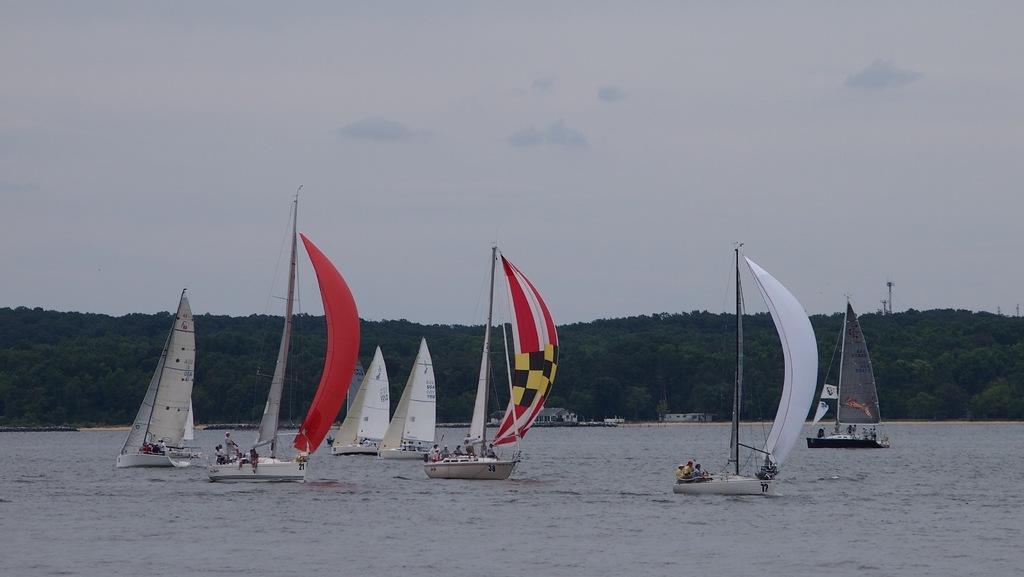Can you describe this image briefly? In this image there is a river and we can see boats on the river. In the background there are hills and sky. 